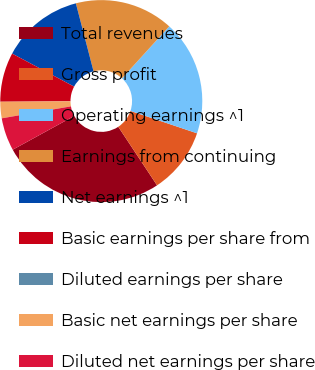Convert chart to OTSL. <chart><loc_0><loc_0><loc_500><loc_500><pie_chart><fcel>Total revenues<fcel>Gross profit<fcel>Operating earnings ^1<fcel>Earnings from continuing<fcel>Net earnings ^1<fcel>Basic earnings per share from<fcel>Diluted earnings per share<fcel>Basic net earnings per share<fcel>Diluted net earnings per share<nl><fcel>26.32%<fcel>10.53%<fcel>18.42%<fcel>15.79%<fcel>13.16%<fcel>7.89%<fcel>0.0%<fcel>2.63%<fcel>5.26%<nl></chart> 